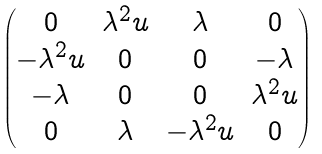<formula> <loc_0><loc_0><loc_500><loc_500>\begin{pmatrix} 0 & \lambda ^ { 2 } u & \lambda & 0 \\ - \lambda ^ { 2 } u & 0 & 0 & - \lambda \\ - \lambda & 0 & 0 & \lambda ^ { 2 } u \\ 0 & \lambda & - \lambda ^ { 2 } u & 0 \end{pmatrix}</formula> 